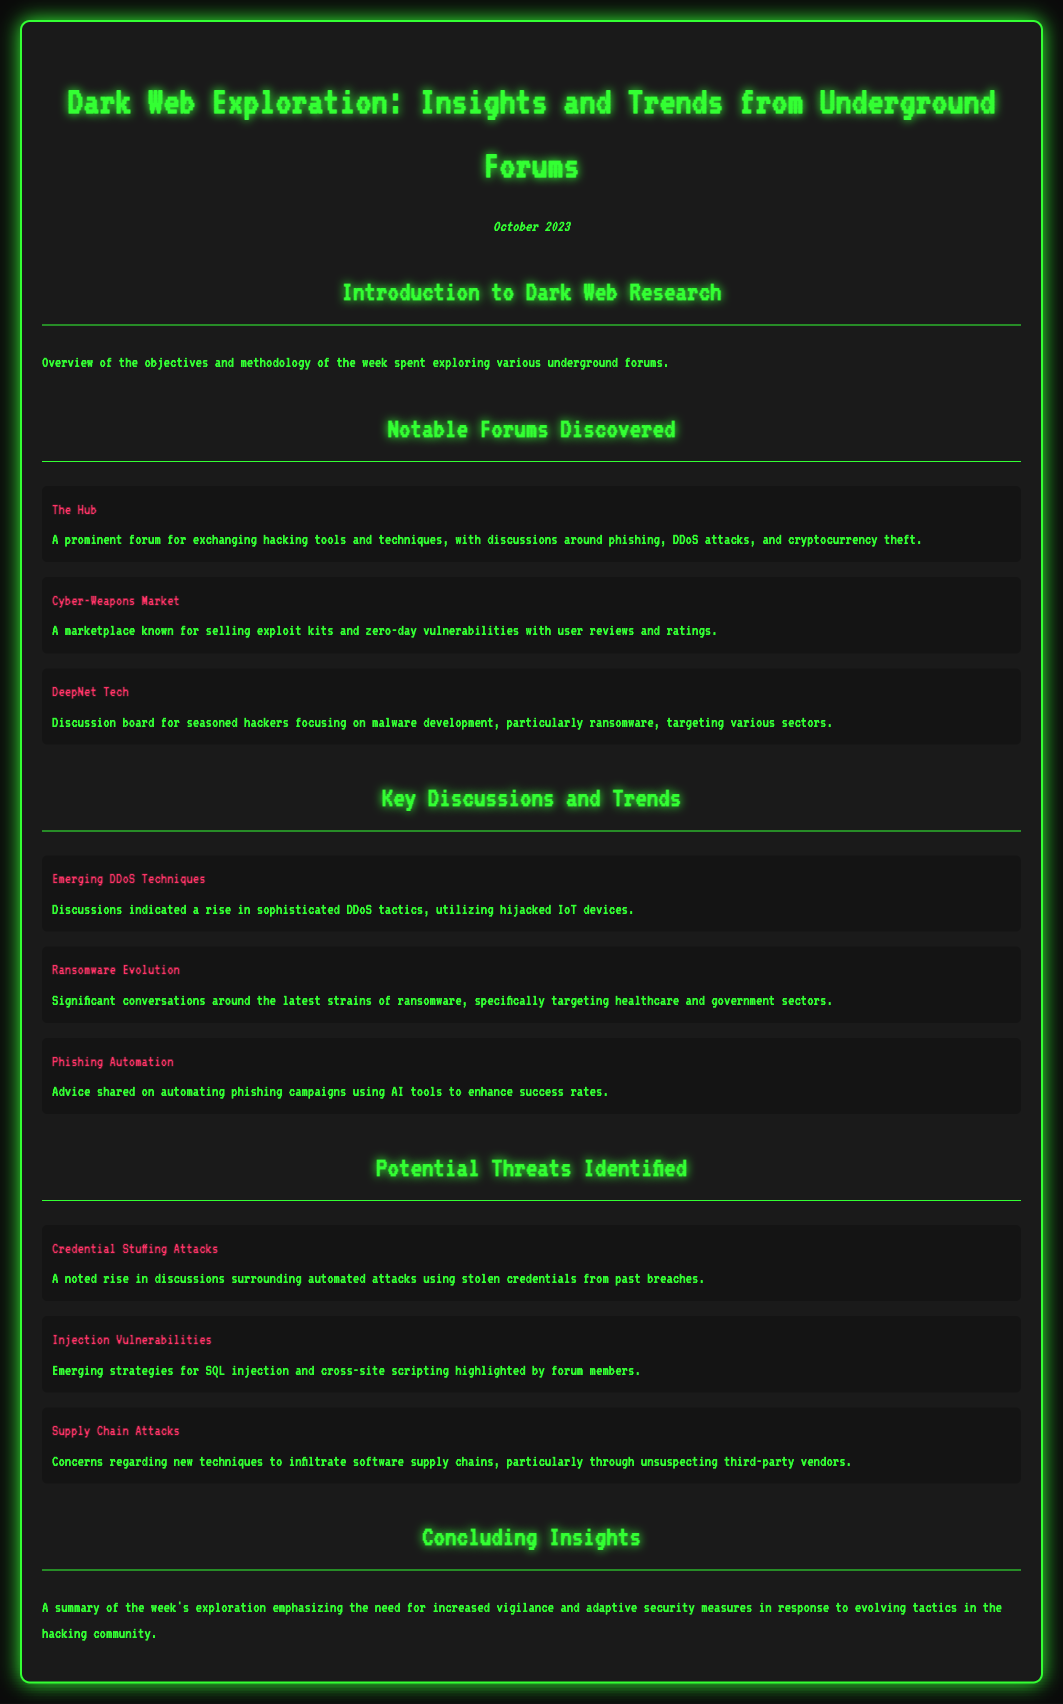What is the title of the document? The title is a prominent heading at the top of the document.
Answer: Dark Web Exploration: Insights and Trends from Underground Forums How many notable forums are discovered? The number of notable forums is listed in the document under the corresponding section.
Answer: 3 What threat involves ancient credentials? This threat is specifically addressed in the Potential Threats Identified section of the document.
Answer: Credential Stuffing Attacks Which forum focuses on malware development? This forum is highlighted in the Notable Forums Discovered section, indicating its specific focus area.
Answer: DeepNet Tech What topic discusses automation of phishing campaigns? The document mentions this topic in the Key Discussions and Trends section.
Answer: Phishing Automation Which threat relates to software supply chains? This specific threat appears in the Potential Threats Identified section of the document.
Answer: Supply Chain Attacks What month is the exploration report from? This information is found in the date section included in the document.
Answer: October 2023 What is a major trend in DDoS tactics? The insights under Key Discussions and Trends address this specific trend.
Answer: Sophisticated DDoS tactics 